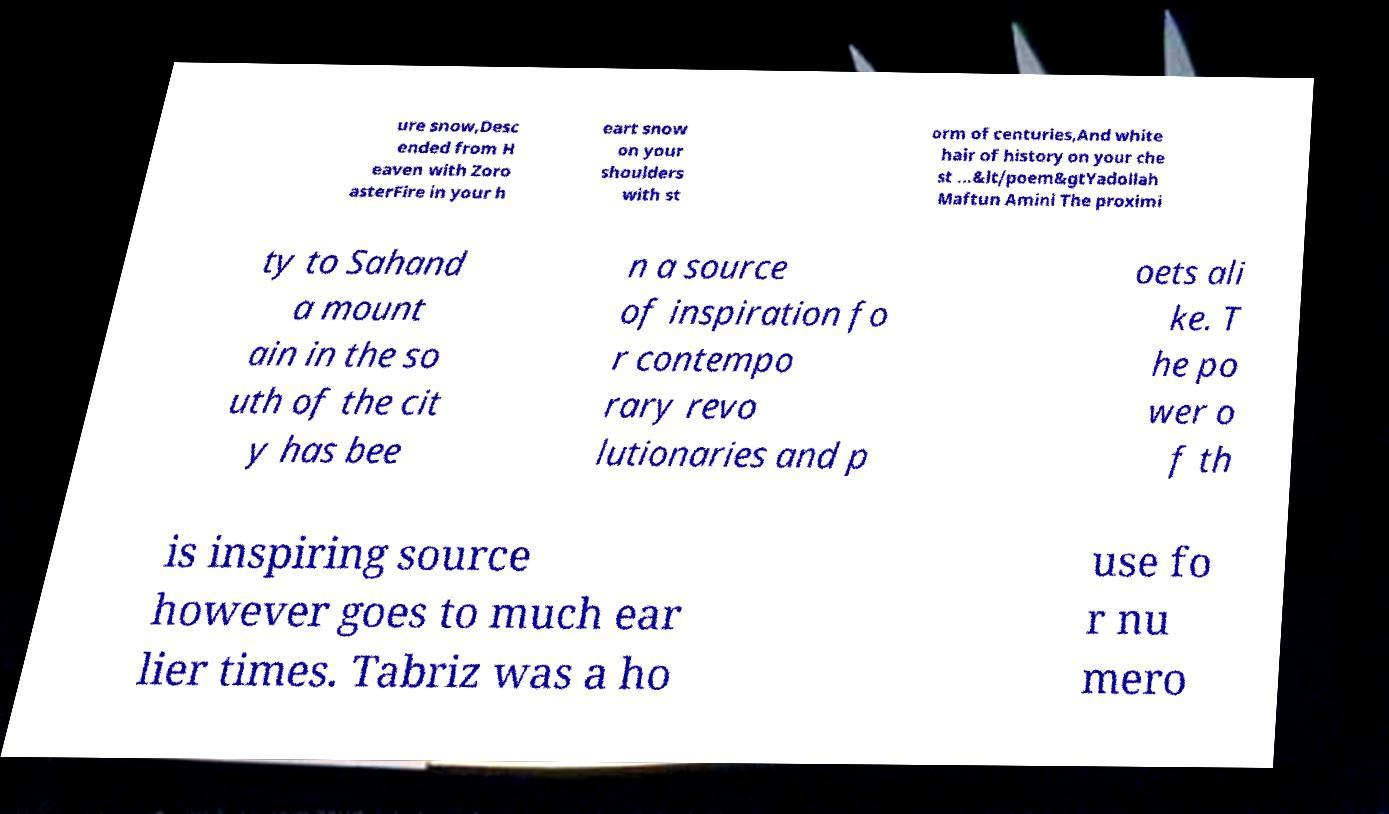Can you read and provide the text displayed in the image?This photo seems to have some interesting text. Can you extract and type it out for me? ure snow,Desc ended from H eaven with Zoro asterFire in your h eart snow on your shoulders with st orm of centuries,And white hair of history on your che st ...&lt/poem&gtYadollah Maftun Amini The proximi ty to Sahand a mount ain in the so uth of the cit y has bee n a source of inspiration fo r contempo rary revo lutionaries and p oets ali ke. T he po wer o f th is inspiring source however goes to much ear lier times. Tabriz was a ho use fo r nu mero 